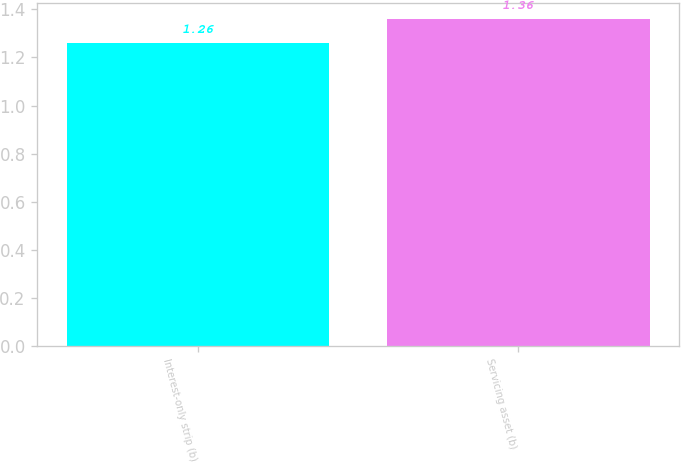<chart> <loc_0><loc_0><loc_500><loc_500><bar_chart><fcel>Interest-only strip (b)<fcel>Servicing asset (b)<nl><fcel>1.26<fcel>1.36<nl></chart> 